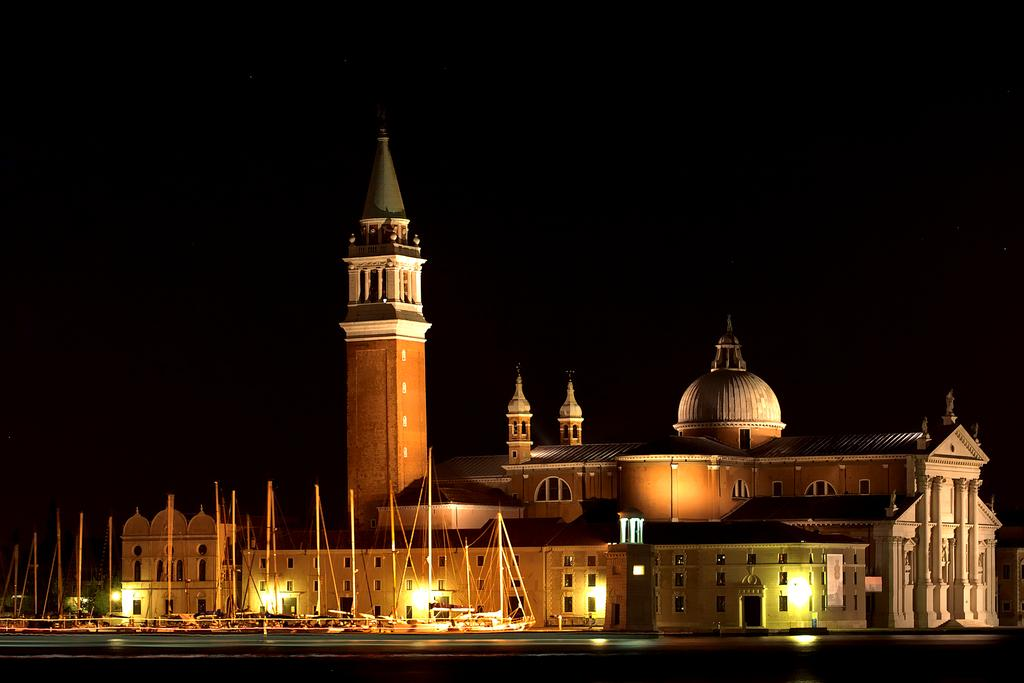What type of structures can be seen in the image? There are buildings in the image. What else is visible in the image besides the buildings? There are lights, trees, and boats visible in the image. What type of recess can be seen in the image? There is no recess present in the image. What type of approval is being given in the image? There is no approval process depicted in the image. 